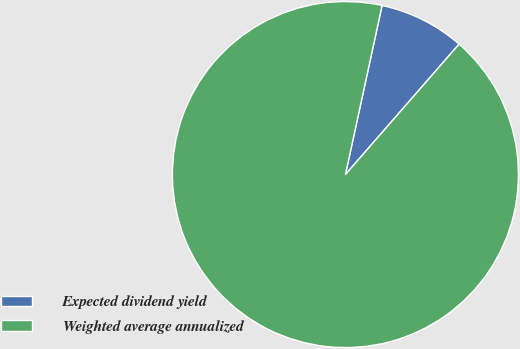<chart> <loc_0><loc_0><loc_500><loc_500><pie_chart><fcel>Expected dividend yield<fcel>Weighted average annualized<nl><fcel>8.01%<fcel>91.99%<nl></chart> 